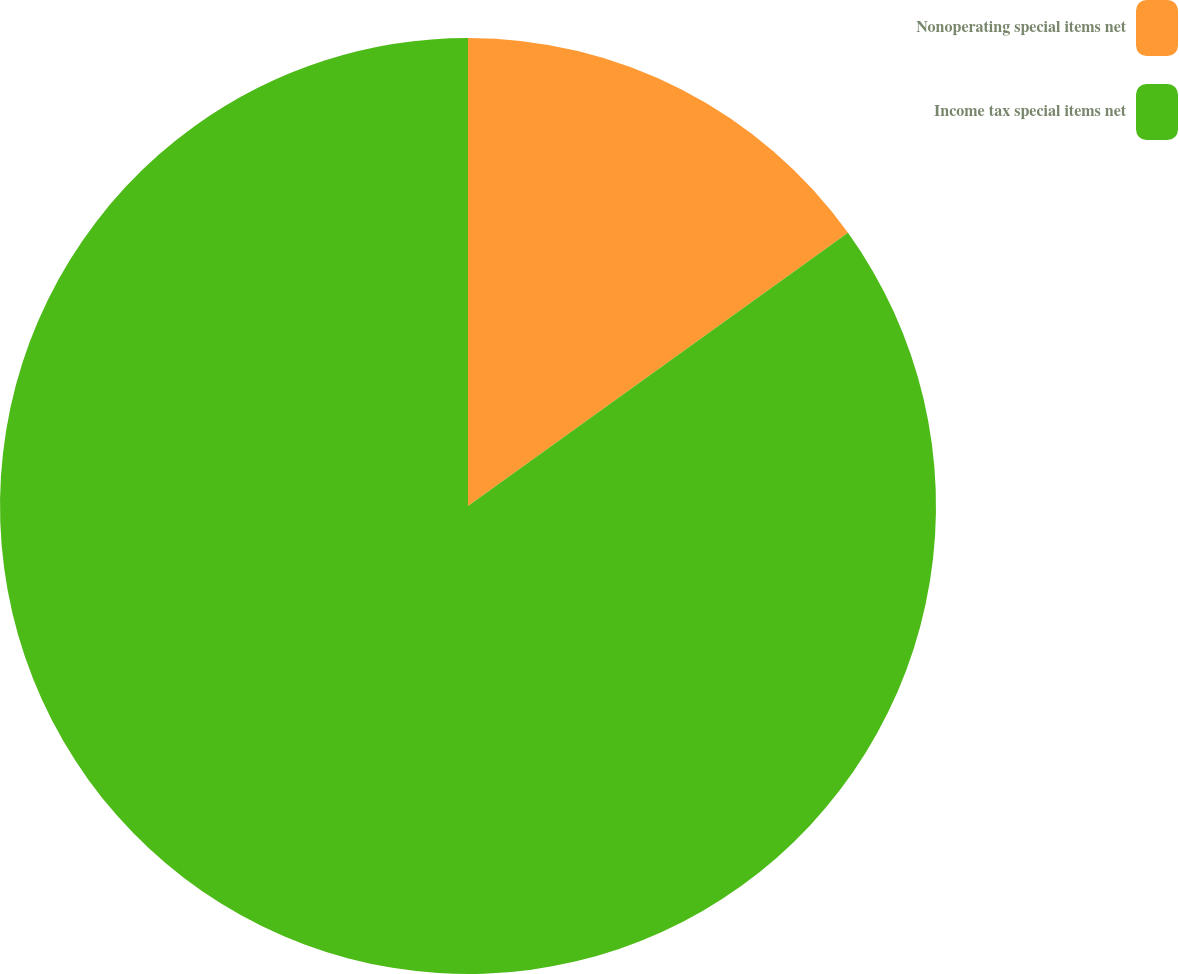Convert chart to OTSL. <chart><loc_0><loc_0><loc_500><loc_500><pie_chart><fcel>Nonoperating special items net<fcel>Income tax special items net<nl><fcel>15.08%<fcel>84.92%<nl></chart> 